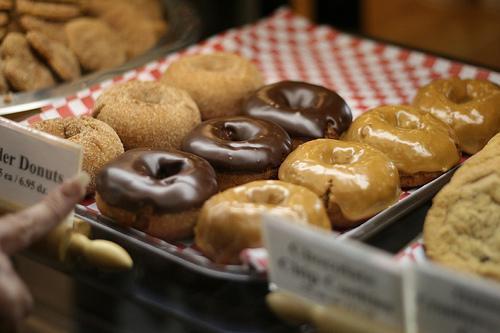How many chocolate donuts are there?
Give a very brief answer. 3. How many donuts are there?
Give a very brief answer. 10. How many suv cars are in the picture?
Give a very brief answer. 0. 